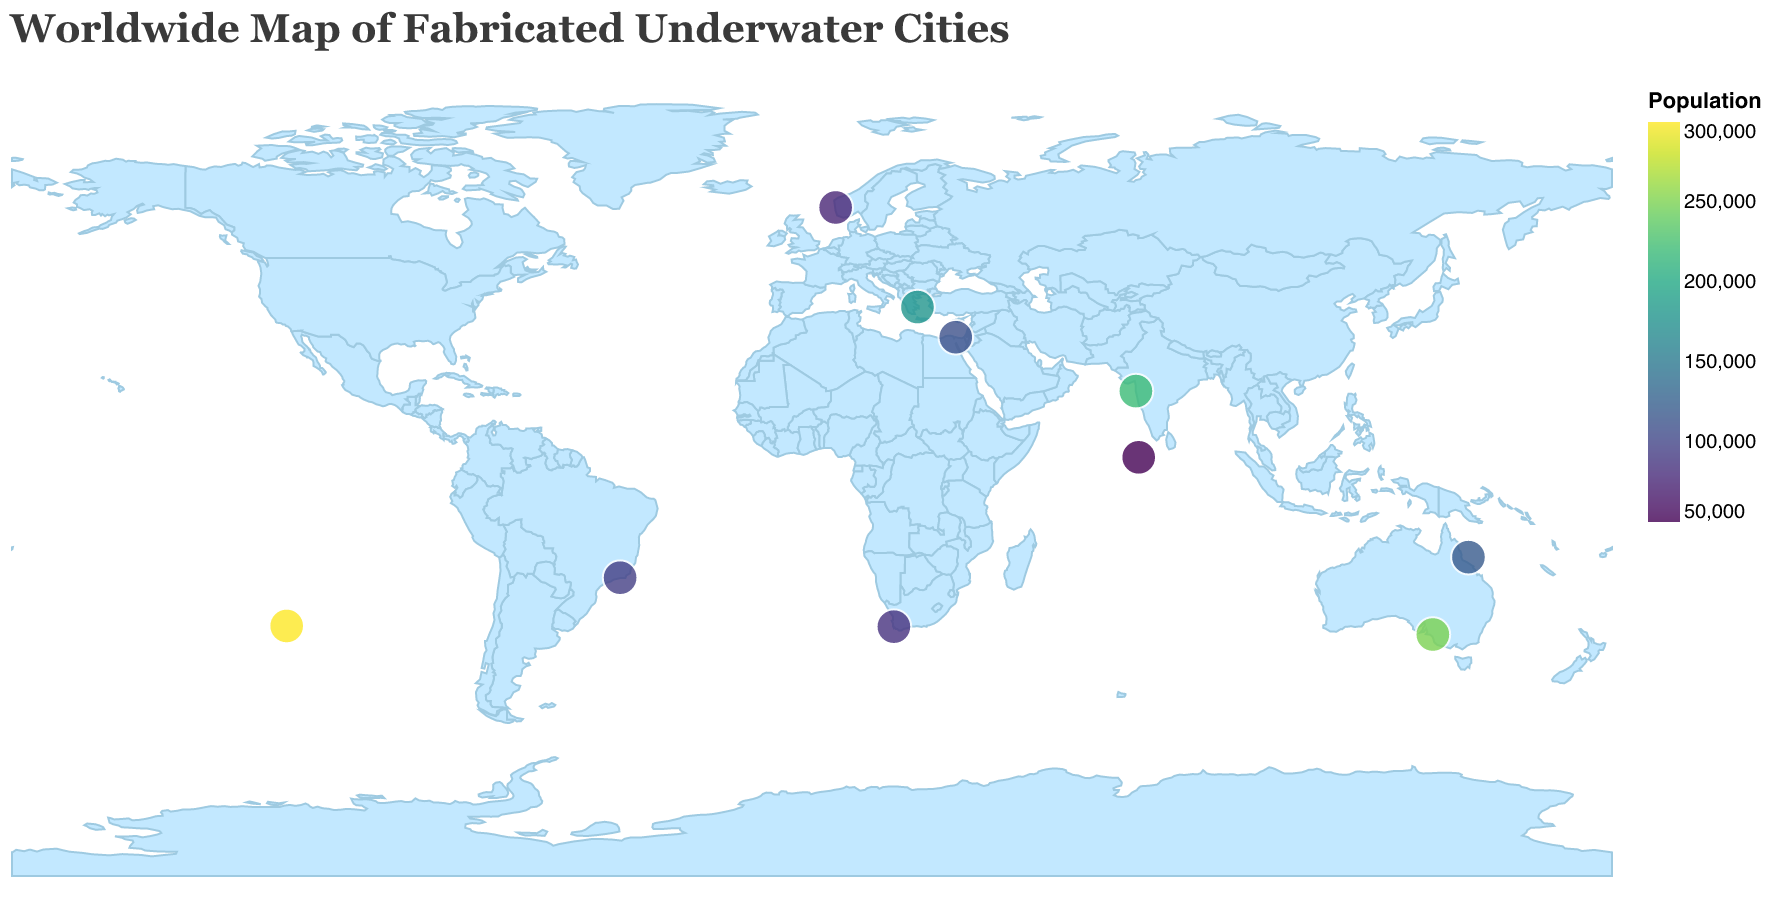What's the title of the figure? The title is the text at the top of the figure.
Answer: Worldwide Map of Fabricated Underwater Cities Which underwater city has the highest population? Look for the city with the darkest color (representing higher values in the population color scale) and check its tooltip information.
Answer: Aquapolis What is the year founded for Coral Haven? Find Coral Haven on the map and hover over it to see the tooltip with the founding year.
Answer: 1999 How many underwater cities were founded in the '90s? Check the Year_Founded in the tooltips for each city and count those within the range from 1990 to 1999.
Answer: 2 Which country has the largest underwater city by population? Identify the city with the highest population from the tooltips and note its country.
Answer: United States What is the difference in population between Atlantis Tokyo and Submerso? Find the populations of both cities in their tooltips and subtract the smaller from the larger.
Answer: 155000 Which underwater city is closest to 0 degrees latitude? Identify the city with the latitude closest to 0 by checking the tooltip latitudes.
Answer: Bubble Atoll How many underwater cities have a population of over 200,000? Check the population in the tooltips of each city and count those with values greater than 200,000.
Answer: 3 Is Aquapolis in the eastern or western hemisphere? Check Aquapolis's tooltip for its longitude. Longitudes less than 0 are in the western hemisphere, while those greater than 0 are in the eastern hemisphere.
Answer: western What is the average population of the underwater cities founded after 2000? Identify cities founded after 2000 from the Year_Founded in their tooltips, sum their populations, and divide by the number of such cities. Detailed explanation:  (Submerso: 95000 + Nemo Nagar: 220000 + Bubble Atoll: 50000) / 3 = 365000 / 3
Answer: 121667 